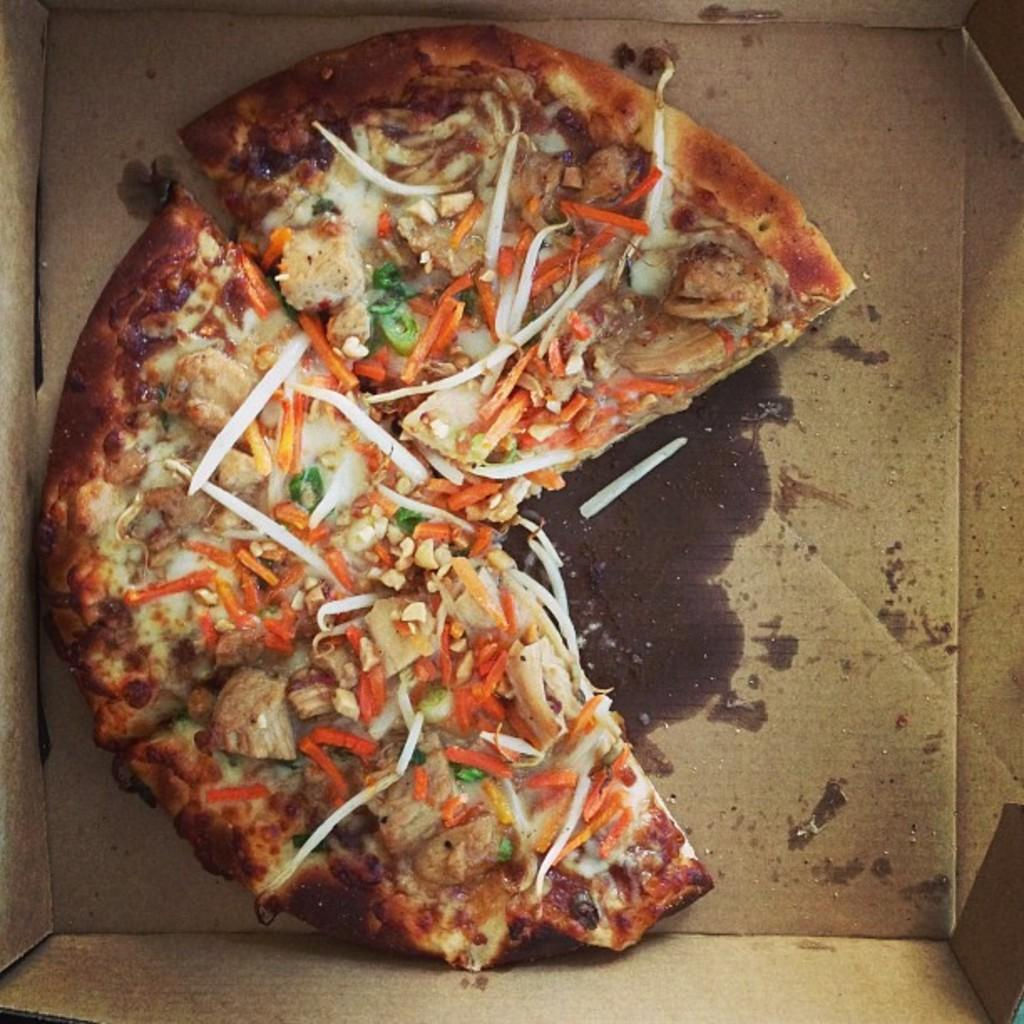What type of food is shown in the image? There is a pizza in the image. How is the pizza being stored or transported? The pizza is in a cardboard box. What toppings can be seen on the pizza? There are vegetable slices on the pizza. What tax rate is applied to the pizza in the image? There is no information about tax rates in the image, as it only shows a pizza in a cardboard box with vegetable slices. 